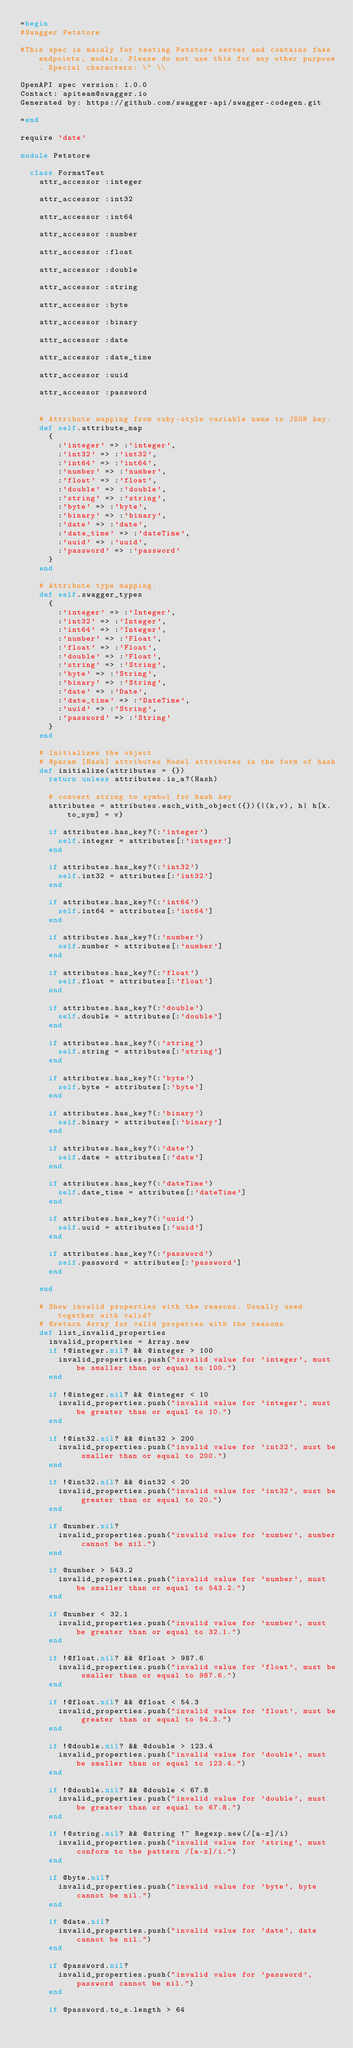<code> <loc_0><loc_0><loc_500><loc_500><_Ruby_>=begin
#Swagger Petstore

#This spec is mainly for testing Petstore server and contains fake endpoints, models. Please do not use this for any other purpose. Special characters: \" \\

OpenAPI spec version: 1.0.0
Contact: apiteam@swagger.io
Generated by: https://github.com/swagger-api/swagger-codegen.git

=end

require 'date'

module Petstore

  class FormatTest
    attr_accessor :integer

    attr_accessor :int32

    attr_accessor :int64

    attr_accessor :number

    attr_accessor :float

    attr_accessor :double

    attr_accessor :string

    attr_accessor :byte

    attr_accessor :binary

    attr_accessor :date

    attr_accessor :date_time

    attr_accessor :uuid

    attr_accessor :password


    # Attribute mapping from ruby-style variable name to JSON key.
    def self.attribute_map
      {
        :'integer' => :'integer',
        :'int32' => :'int32',
        :'int64' => :'int64',
        :'number' => :'number',
        :'float' => :'float',
        :'double' => :'double',
        :'string' => :'string',
        :'byte' => :'byte',
        :'binary' => :'binary',
        :'date' => :'date',
        :'date_time' => :'dateTime',
        :'uuid' => :'uuid',
        :'password' => :'password'
      }
    end

    # Attribute type mapping.
    def self.swagger_types
      {
        :'integer' => :'Integer',
        :'int32' => :'Integer',
        :'int64' => :'Integer',
        :'number' => :'Float',
        :'float' => :'Float',
        :'double' => :'Float',
        :'string' => :'String',
        :'byte' => :'String',
        :'binary' => :'String',
        :'date' => :'Date',
        :'date_time' => :'DateTime',
        :'uuid' => :'String',
        :'password' => :'String'
      }
    end

    # Initializes the object
    # @param [Hash] attributes Model attributes in the form of hash
    def initialize(attributes = {})
      return unless attributes.is_a?(Hash)

      # convert string to symbol for hash key
      attributes = attributes.each_with_object({}){|(k,v), h| h[k.to_sym] = v}

      if attributes.has_key?(:'integer')
        self.integer = attributes[:'integer']
      end

      if attributes.has_key?(:'int32')
        self.int32 = attributes[:'int32']
      end

      if attributes.has_key?(:'int64')
        self.int64 = attributes[:'int64']
      end

      if attributes.has_key?(:'number')
        self.number = attributes[:'number']
      end

      if attributes.has_key?(:'float')
        self.float = attributes[:'float']
      end

      if attributes.has_key?(:'double')
        self.double = attributes[:'double']
      end

      if attributes.has_key?(:'string')
        self.string = attributes[:'string']
      end

      if attributes.has_key?(:'byte')
        self.byte = attributes[:'byte']
      end

      if attributes.has_key?(:'binary')
        self.binary = attributes[:'binary']
      end

      if attributes.has_key?(:'date')
        self.date = attributes[:'date']
      end

      if attributes.has_key?(:'dateTime')
        self.date_time = attributes[:'dateTime']
      end

      if attributes.has_key?(:'uuid')
        self.uuid = attributes[:'uuid']
      end

      if attributes.has_key?(:'password')
        self.password = attributes[:'password']
      end

    end

    # Show invalid properties with the reasons. Usually used together with valid?
    # @return Array for valid properies with the reasons
    def list_invalid_properties
      invalid_properties = Array.new
      if !@integer.nil? && @integer > 100
        invalid_properties.push("invalid value for 'integer', must be smaller than or equal to 100.")
      end

      if !@integer.nil? && @integer < 10
        invalid_properties.push("invalid value for 'integer', must be greater than or equal to 10.")
      end

      if !@int32.nil? && @int32 > 200
        invalid_properties.push("invalid value for 'int32', must be smaller than or equal to 200.")
      end

      if !@int32.nil? && @int32 < 20
        invalid_properties.push("invalid value for 'int32', must be greater than or equal to 20.")
      end

      if @number.nil?
        invalid_properties.push("invalid value for 'number', number cannot be nil.")
      end

      if @number > 543.2
        invalid_properties.push("invalid value for 'number', must be smaller than or equal to 543.2.")
      end

      if @number < 32.1
        invalid_properties.push("invalid value for 'number', must be greater than or equal to 32.1.")
      end

      if !@float.nil? && @float > 987.6
        invalid_properties.push("invalid value for 'float', must be smaller than or equal to 987.6.")
      end

      if !@float.nil? && @float < 54.3
        invalid_properties.push("invalid value for 'float', must be greater than or equal to 54.3.")
      end

      if !@double.nil? && @double > 123.4
        invalid_properties.push("invalid value for 'double', must be smaller than or equal to 123.4.")
      end

      if !@double.nil? && @double < 67.8
        invalid_properties.push("invalid value for 'double', must be greater than or equal to 67.8.")
      end

      if !@string.nil? && @string !~ Regexp.new(/[a-z]/i)
        invalid_properties.push("invalid value for 'string', must conform to the pattern /[a-z]/i.")
      end

      if @byte.nil?
        invalid_properties.push("invalid value for 'byte', byte cannot be nil.")
      end

      if @date.nil?
        invalid_properties.push("invalid value for 'date', date cannot be nil.")
      end

      if @password.nil?
        invalid_properties.push("invalid value for 'password', password cannot be nil.")
      end

      if @password.to_s.length > 64</code> 